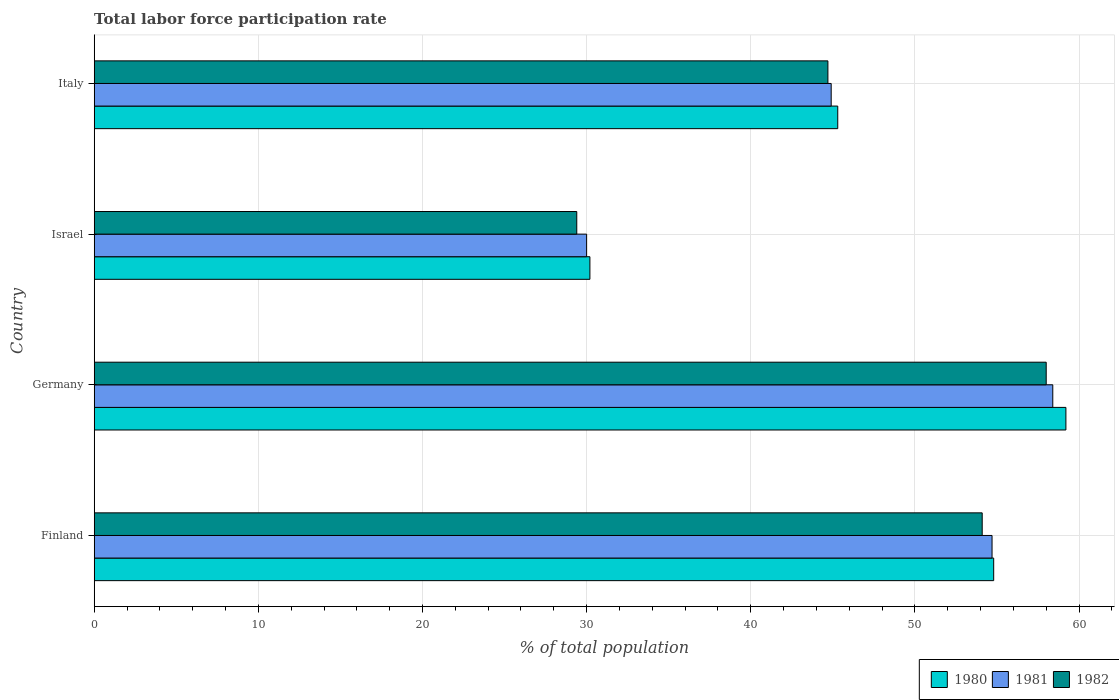How many different coloured bars are there?
Your answer should be very brief. 3. Are the number of bars per tick equal to the number of legend labels?
Provide a short and direct response. Yes. How many bars are there on the 3rd tick from the bottom?
Offer a terse response. 3. In how many cases, is the number of bars for a given country not equal to the number of legend labels?
Offer a very short reply. 0. What is the total labor force participation rate in 1980 in Germany?
Give a very brief answer. 59.2. Across all countries, what is the minimum total labor force participation rate in 1982?
Your answer should be compact. 29.4. What is the total total labor force participation rate in 1980 in the graph?
Ensure brevity in your answer.  189.5. What is the difference between the total labor force participation rate in 1982 in Germany and that in Italy?
Your answer should be very brief. 13.3. What is the difference between the total labor force participation rate in 1980 in Israel and the total labor force participation rate in 1981 in Finland?
Provide a succinct answer. -24.5. What is the average total labor force participation rate in 1981 per country?
Provide a succinct answer. 47. What is the difference between the total labor force participation rate in 1981 and total labor force participation rate in 1980 in Italy?
Provide a short and direct response. -0.4. In how many countries, is the total labor force participation rate in 1981 greater than 46 %?
Make the answer very short. 2. What is the ratio of the total labor force participation rate in 1980 in Finland to that in Italy?
Provide a succinct answer. 1.21. Is the total labor force participation rate in 1982 in Finland less than that in Italy?
Keep it short and to the point. No. Is the difference between the total labor force participation rate in 1981 in Germany and Italy greater than the difference between the total labor force participation rate in 1980 in Germany and Italy?
Your response must be concise. No. What is the difference between the highest and the second highest total labor force participation rate in 1980?
Keep it short and to the point. 4.4. What is the difference between the highest and the lowest total labor force participation rate in 1980?
Your answer should be compact. 29. In how many countries, is the total labor force participation rate in 1982 greater than the average total labor force participation rate in 1982 taken over all countries?
Keep it short and to the point. 2. Is the sum of the total labor force participation rate in 1981 in Finland and Israel greater than the maximum total labor force participation rate in 1980 across all countries?
Make the answer very short. Yes. What does the 1st bar from the top in Finland represents?
Make the answer very short. 1982. Is it the case that in every country, the sum of the total labor force participation rate in 1980 and total labor force participation rate in 1981 is greater than the total labor force participation rate in 1982?
Ensure brevity in your answer.  Yes. How many bars are there?
Offer a terse response. 12. How many countries are there in the graph?
Provide a succinct answer. 4. Where does the legend appear in the graph?
Your answer should be very brief. Bottom right. How many legend labels are there?
Ensure brevity in your answer.  3. What is the title of the graph?
Make the answer very short. Total labor force participation rate. Does "1963" appear as one of the legend labels in the graph?
Offer a terse response. No. What is the label or title of the X-axis?
Provide a short and direct response. % of total population. What is the % of total population of 1980 in Finland?
Keep it short and to the point. 54.8. What is the % of total population of 1981 in Finland?
Your answer should be very brief. 54.7. What is the % of total population in 1982 in Finland?
Ensure brevity in your answer.  54.1. What is the % of total population in 1980 in Germany?
Your answer should be very brief. 59.2. What is the % of total population in 1981 in Germany?
Your answer should be compact. 58.4. What is the % of total population in 1982 in Germany?
Provide a short and direct response. 58. What is the % of total population in 1980 in Israel?
Give a very brief answer. 30.2. What is the % of total population in 1981 in Israel?
Your response must be concise. 30. What is the % of total population of 1982 in Israel?
Give a very brief answer. 29.4. What is the % of total population of 1980 in Italy?
Provide a succinct answer. 45.3. What is the % of total population of 1981 in Italy?
Ensure brevity in your answer.  44.9. What is the % of total population of 1982 in Italy?
Your response must be concise. 44.7. Across all countries, what is the maximum % of total population in 1980?
Your answer should be compact. 59.2. Across all countries, what is the maximum % of total population in 1981?
Keep it short and to the point. 58.4. Across all countries, what is the minimum % of total population in 1980?
Offer a terse response. 30.2. Across all countries, what is the minimum % of total population of 1981?
Keep it short and to the point. 30. Across all countries, what is the minimum % of total population in 1982?
Provide a short and direct response. 29.4. What is the total % of total population of 1980 in the graph?
Your answer should be compact. 189.5. What is the total % of total population in 1981 in the graph?
Your answer should be compact. 188. What is the total % of total population in 1982 in the graph?
Give a very brief answer. 186.2. What is the difference between the % of total population in 1980 in Finland and that in Germany?
Keep it short and to the point. -4.4. What is the difference between the % of total population in 1982 in Finland and that in Germany?
Your answer should be compact. -3.9. What is the difference between the % of total population in 1980 in Finland and that in Israel?
Make the answer very short. 24.6. What is the difference between the % of total population in 1981 in Finland and that in Israel?
Give a very brief answer. 24.7. What is the difference between the % of total population in 1982 in Finland and that in Israel?
Offer a very short reply. 24.7. What is the difference between the % of total population of 1980 in Finland and that in Italy?
Provide a succinct answer. 9.5. What is the difference between the % of total population of 1980 in Germany and that in Israel?
Make the answer very short. 29. What is the difference between the % of total population in 1981 in Germany and that in Israel?
Your answer should be very brief. 28.4. What is the difference between the % of total population in 1982 in Germany and that in Israel?
Keep it short and to the point. 28.6. What is the difference between the % of total population of 1980 in Germany and that in Italy?
Your answer should be compact. 13.9. What is the difference between the % of total population of 1982 in Germany and that in Italy?
Provide a succinct answer. 13.3. What is the difference between the % of total population of 1980 in Israel and that in Italy?
Ensure brevity in your answer.  -15.1. What is the difference between the % of total population of 1981 in Israel and that in Italy?
Keep it short and to the point. -14.9. What is the difference between the % of total population in 1982 in Israel and that in Italy?
Offer a terse response. -15.3. What is the difference between the % of total population of 1980 in Finland and the % of total population of 1982 in Germany?
Keep it short and to the point. -3.2. What is the difference between the % of total population of 1980 in Finland and the % of total population of 1981 in Israel?
Your answer should be very brief. 24.8. What is the difference between the % of total population in 1980 in Finland and the % of total population in 1982 in Israel?
Offer a terse response. 25.4. What is the difference between the % of total population of 1981 in Finland and the % of total population of 1982 in Israel?
Provide a succinct answer. 25.3. What is the difference between the % of total population in 1980 in Finland and the % of total population in 1982 in Italy?
Offer a terse response. 10.1. What is the difference between the % of total population in 1981 in Finland and the % of total population in 1982 in Italy?
Provide a short and direct response. 10. What is the difference between the % of total population of 1980 in Germany and the % of total population of 1981 in Israel?
Provide a short and direct response. 29.2. What is the difference between the % of total population in 1980 in Germany and the % of total population in 1982 in Israel?
Give a very brief answer. 29.8. What is the difference between the % of total population of 1980 in Germany and the % of total population of 1981 in Italy?
Your answer should be very brief. 14.3. What is the difference between the % of total population of 1980 in Germany and the % of total population of 1982 in Italy?
Make the answer very short. 14.5. What is the difference between the % of total population of 1981 in Germany and the % of total population of 1982 in Italy?
Your response must be concise. 13.7. What is the difference between the % of total population of 1980 in Israel and the % of total population of 1981 in Italy?
Offer a terse response. -14.7. What is the difference between the % of total population in 1981 in Israel and the % of total population in 1982 in Italy?
Your response must be concise. -14.7. What is the average % of total population of 1980 per country?
Provide a short and direct response. 47.38. What is the average % of total population in 1982 per country?
Provide a succinct answer. 46.55. What is the difference between the % of total population of 1980 and % of total population of 1981 in Finland?
Your answer should be very brief. 0.1. What is the difference between the % of total population in 1980 and % of total population in 1981 in Germany?
Your answer should be very brief. 0.8. What is the difference between the % of total population in 1980 and % of total population in 1982 in Germany?
Give a very brief answer. 1.2. What is the difference between the % of total population of 1980 and % of total population of 1982 in Israel?
Offer a very short reply. 0.8. What is the difference between the % of total population in 1981 and % of total population in 1982 in Israel?
Your response must be concise. 0.6. What is the difference between the % of total population of 1980 and % of total population of 1981 in Italy?
Make the answer very short. 0.4. What is the difference between the % of total population of 1980 and % of total population of 1982 in Italy?
Your answer should be compact. 0.6. What is the ratio of the % of total population of 1980 in Finland to that in Germany?
Offer a very short reply. 0.93. What is the ratio of the % of total population of 1981 in Finland to that in Germany?
Offer a terse response. 0.94. What is the ratio of the % of total population in 1982 in Finland to that in Germany?
Provide a short and direct response. 0.93. What is the ratio of the % of total population of 1980 in Finland to that in Israel?
Offer a very short reply. 1.81. What is the ratio of the % of total population of 1981 in Finland to that in Israel?
Give a very brief answer. 1.82. What is the ratio of the % of total population of 1982 in Finland to that in Israel?
Ensure brevity in your answer.  1.84. What is the ratio of the % of total population of 1980 in Finland to that in Italy?
Make the answer very short. 1.21. What is the ratio of the % of total population in 1981 in Finland to that in Italy?
Your answer should be very brief. 1.22. What is the ratio of the % of total population of 1982 in Finland to that in Italy?
Your answer should be very brief. 1.21. What is the ratio of the % of total population in 1980 in Germany to that in Israel?
Your answer should be compact. 1.96. What is the ratio of the % of total population in 1981 in Germany to that in Israel?
Keep it short and to the point. 1.95. What is the ratio of the % of total population of 1982 in Germany to that in Israel?
Give a very brief answer. 1.97. What is the ratio of the % of total population in 1980 in Germany to that in Italy?
Your answer should be compact. 1.31. What is the ratio of the % of total population in 1981 in Germany to that in Italy?
Ensure brevity in your answer.  1.3. What is the ratio of the % of total population of 1982 in Germany to that in Italy?
Your response must be concise. 1.3. What is the ratio of the % of total population of 1980 in Israel to that in Italy?
Give a very brief answer. 0.67. What is the ratio of the % of total population of 1981 in Israel to that in Italy?
Make the answer very short. 0.67. What is the ratio of the % of total population of 1982 in Israel to that in Italy?
Your answer should be very brief. 0.66. What is the difference between the highest and the lowest % of total population of 1981?
Offer a very short reply. 28.4. What is the difference between the highest and the lowest % of total population in 1982?
Offer a terse response. 28.6. 